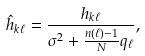Convert formula to latex. <formula><loc_0><loc_0><loc_500><loc_500>\hat { h } _ { k \ell } = \frac { h _ { k \ell } } { \sigma ^ { 2 } + \frac { n ( \ell ) - 1 } { N } q _ { \ell } } ,</formula> 